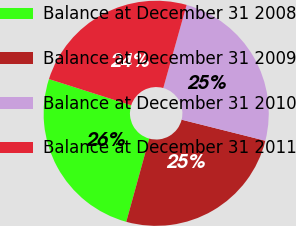<chart> <loc_0><loc_0><loc_500><loc_500><pie_chart><fcel>Balance at December 31 2008<fcel>Balance at December 31 2009<fcel>Balance at December 31 2010<fcel>Balance at December 31 2011<nl><fcel>25.63%<fcel>25.36%<fcel>24.56%<fcel>24.44%<nl></chart> 